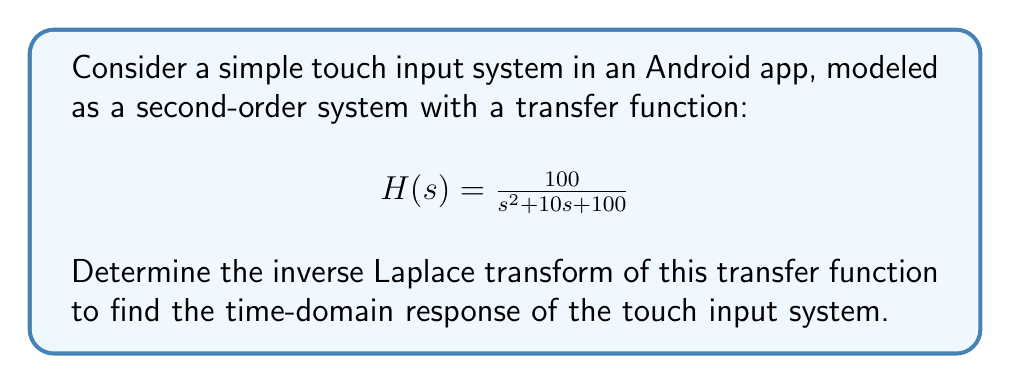Could you help me with this problem? To find the inverse Laplace transform of the given transfer function, we'll follow these steps:

1) First, we need to recognize the standard form of a second-order system:

   $$H(s) = \frac{\omega_n^2}{s^2 + 2\zeta\omega_n s + \omega_n^2}$$

   Where $\omega_n$ is the natural frequency and $\zeta$ is the damping ratio.

2) Comparing our transfer function to the standard form:

   $$H(s) = \frac{100}{s^2 + 10s + 100}$$

   We can see that $\omega_n^2 = 100$, so $\omega_n = 10$ rad/s.

3) To find $\zeta$, we compare the coefficient of $s$ in the denominator:

   $2\zeta\omega_n = 10$
   $2\zeta(10) = 10$
   $\zeta = 0.5$

4) The inverse Laplace transform of a second-order system with $0 < \zeta < 1$ (underdamped) is:

   $$f(t) = 1 - e^{-\zeta\omega_n t} \left(\cos(\omega_d t) + \frac{\zeta}{\sqrt{1-\zeta^2}} \sin(\omega_d t)\right)$$

   Where $\omega_d = \omega_n\sqrt{1-\zeta^2}$ is the damped natural frequency.

5) Calculate $\omega_d$:

   $\omega_d = 10\sqrt{1-0.5^2} = 10\sqrt{0.75} \approx 8.66$ rad/s

6) Now we can substitute all values into the time-domain response equation:

   $$f(t) = 1 - e^{-5t} \left(\cos(8.66t) + \frac{0.5}{\sqrt{1-0.5^2}} \sin(8.66t)\right)$$

   $$f(t) = 1 - e^{-5t} \left(\cos(8.66t) + 0.577 \sin(8.66t)\right)$$

This is the time-domain response of the touch input system.
Answer: $$f(t) = 1 - e^{-5t} (\cos(8.66t) + 0.577 \sin(8.66t))$$ 